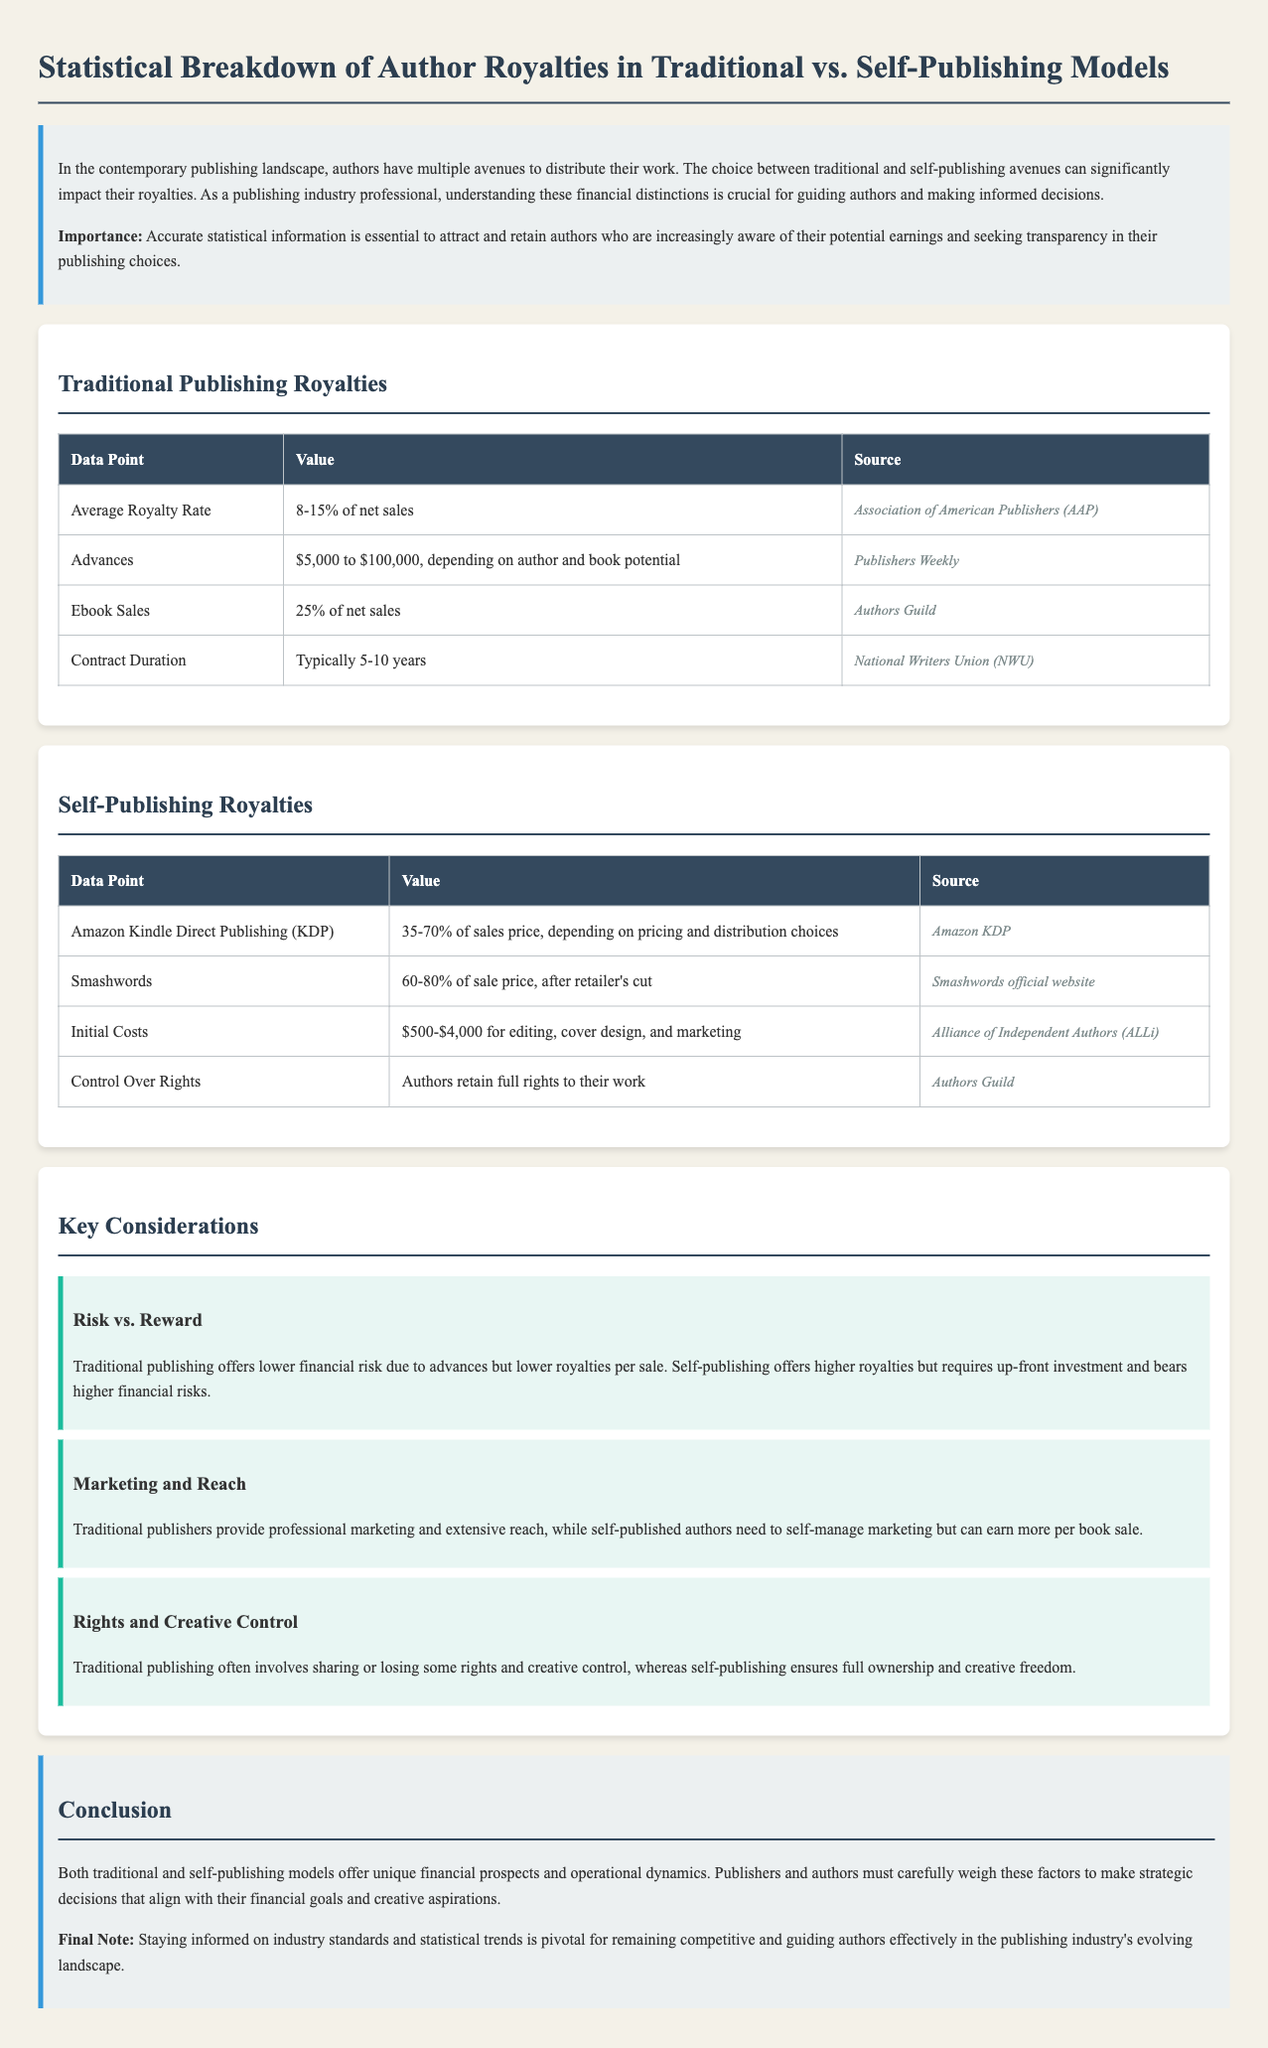What is the average royalty rate for traditional publishing? The average royalty rate for traditional publishing is stated as 8-15% of net sales.
Answer: 8-15% of net sales What is the royalty rate for ebook sales in traditional publishing? The document specifies that the royalty rate for ebook sales is 25% of net sales.
Answer: 25% of net sales What is the range of advances offered by traditional publishers? The advances offered by traditional publishers range from $5,000 to $100,000.
Answer: $5,000 to $100,000 What percentage of sales does Amazon KDP provide? Amazon KDP provides 35-70% of sales price, depending on pricing and distribution choices.
Answer: 35-70% of sales price What are the initial costs for self-publishing? The initial costs for self-publishing range from $500 to $4,000 for various services.
Answer: $500-$4,000 What is a key advantage of self-publishing mentioned in the document? One key advantage of self-publishing mentioned is that authors retain full rights to their work.
Answer: Full rights to their work What does traditional publishing typically require in terms of contract duration? Traditional publishing typically requires a contract duration of 5-10 years.
Answer: 5-10 years What is a key consideration regarding marketing in traditional vs. self-publishing? Traditional publishing provides professional marketing, while self-publishing authors need to self-manage marketing.
Answer: Professional marketing What statement summarizes the conclusion regarding publishing models? The conclusion states that both publishing models offer unique financial prospects and operational dynamics.
Answer: Unique financial prospects and operational dynamics What is the significance of staying informed in the publishing industry? Staying informed on industry standards and statistical trends is pivotal for guiding authors effectively.
Answer: Guiding authors effectively 